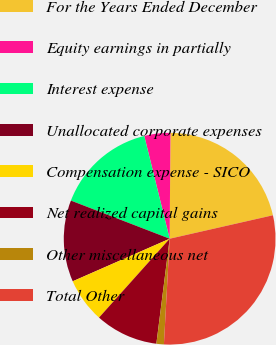<chart> <loc_0><loc_0><loc_500><loc_500><pie_chart><fcel>For the Years Ended December<fcel>Equity earnings in partially<fcel>Interest expense<fcel>Unallocated corporate expenses<fcel>Compensation expense - SICO<fcel>Net realized capital gains<fcel>Other miscellaneous net<fcel>Total Other<nl><fcel>21.33%<fcel>3.97%<fcel>15.28%<fcel>12.45%<fcel>6.79%<fcel>9.62%<fcel>1.14%<fcel>29.42%<nl></chart> 